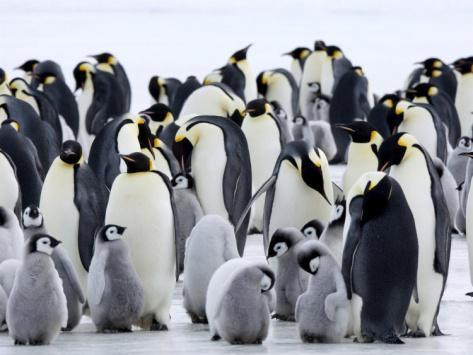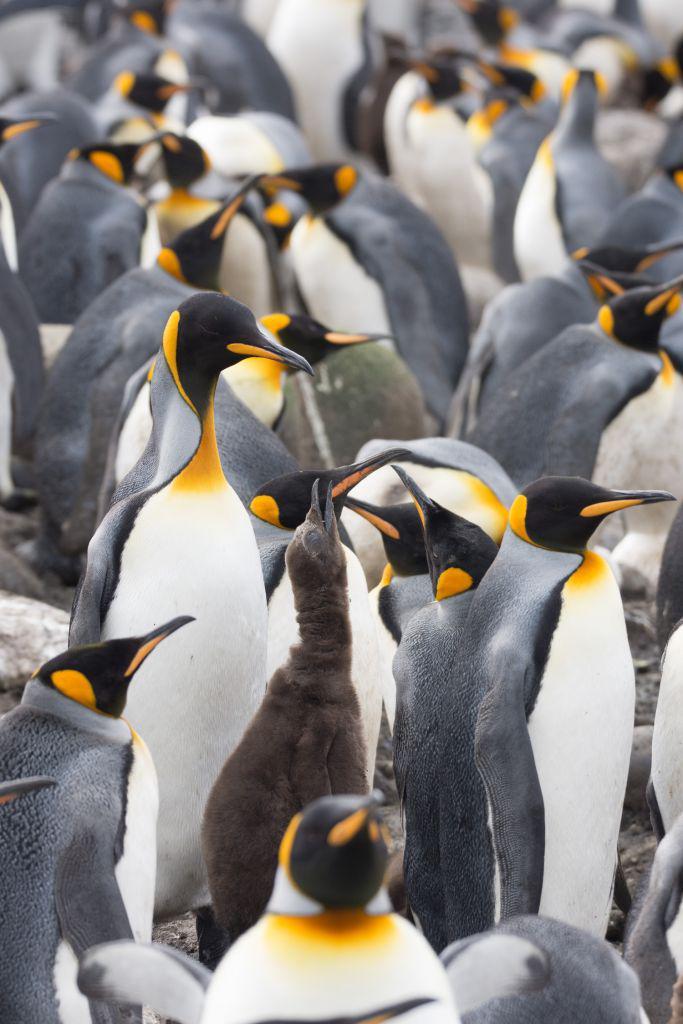The first image is the image on the left, the second image is the image on the right. For the images shown, is this caption "At least one of the penguins has an open beak in one of the images." true? Answer yes or no. Yes. The first image is the image on the left, the second image is the image on the right. Analyze the images presented: Is the assertion "One of the images must contain at least one hundred penguins." valid? Answer yes or no. No. 